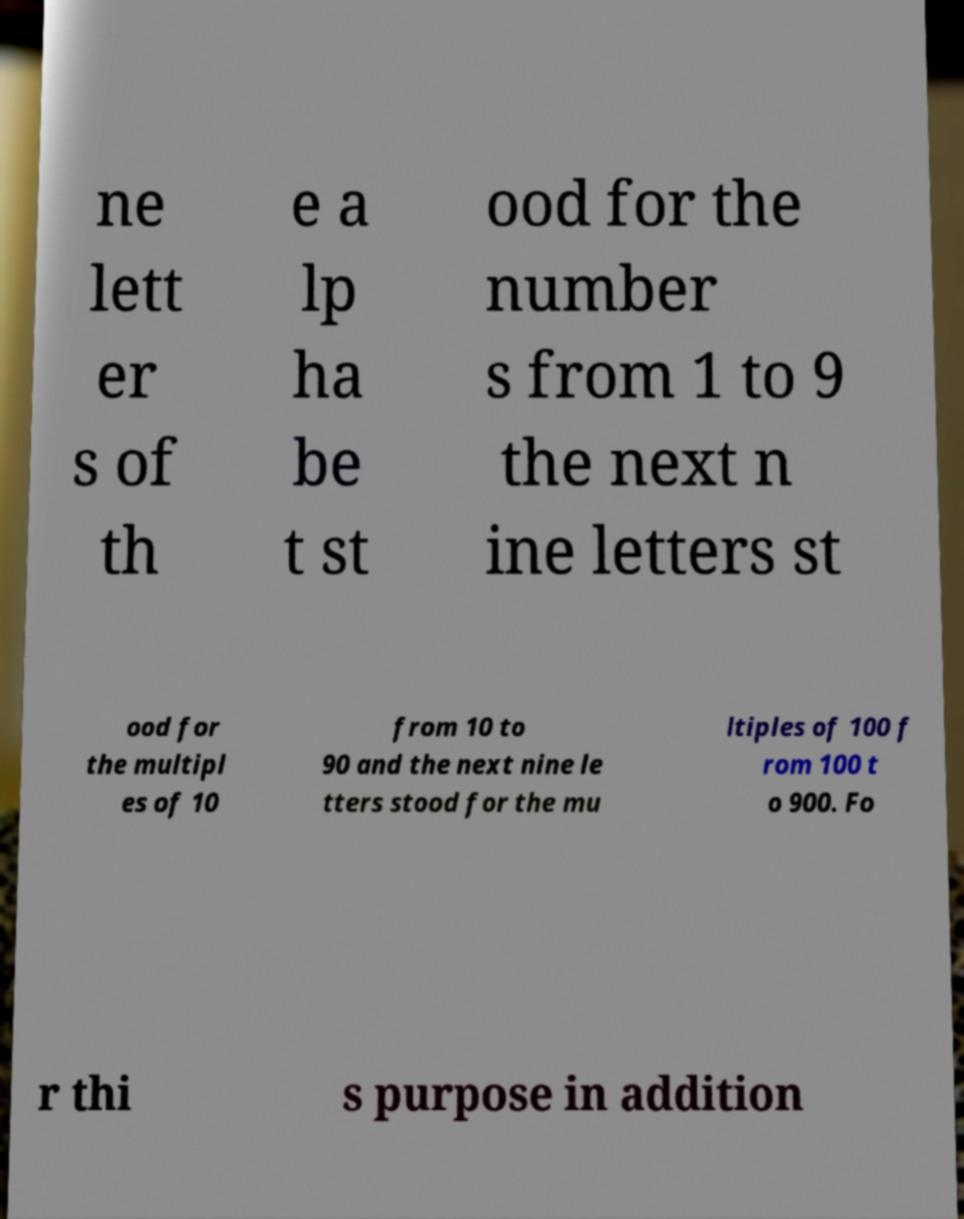I need the written content from this picture converted into text. Can you do that? ne lett er s of th e a lp ha be t st ood for the number s from 1 to 9 the next n ine letters st ood for the multipl es of 10 from 10 to 90 and the next nine le tters stood for the mu ltiples of 100 f rom 100 t o 900. Fo r thi s purpose in addition 